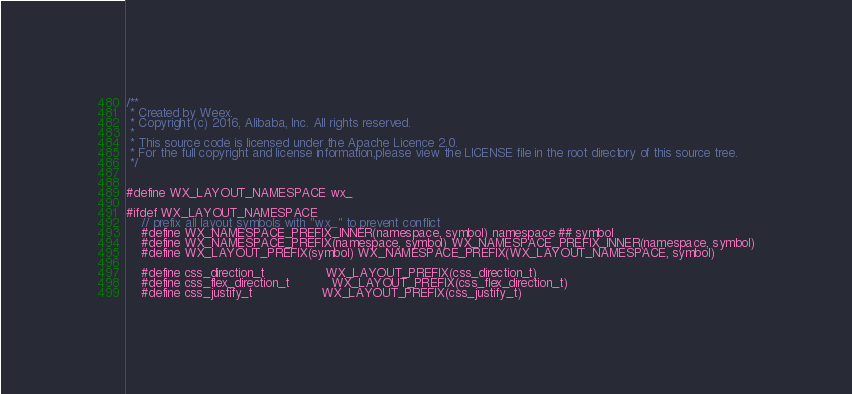<code> <loc_0><loc_0><loc_500><loc_500><_C_>/**
 * Created by Weex.
 * Copyright (c) 2016, Alibaba, Inc. All rights reserved.
 *
 * This source code is licensed under the Apache Licence 2.0.
 * For the full copyright and license information,please view the LICENSE file in the root directory of this source tree.
 */


#define WX_LAYOUT_NAMESPACE wx_

#ifdef WX_LAYOUT_NAMESPACE
    // prefix all layout symbols with "wx_" to prevent conflict
    #define WX_NAMESPACE_PREFIX_INNER(namespace, symbol) namespace ## symbol
    #define WX_NAMESPACE_PREFIX(namespace, symbol) WX_NAMESPACE_PREFIX_INNER(namespace, symbol)
    #define WX_LAYOUT_PREFIX(symbol) WX_NAMESPACE_PREFIX(WX_LAYOUT_NAMESPACE, symbol)

    #define css_direction_t                WX_LAYOUT_PREFIX(css_direction_t)
    #define css_flex_direction_t           WX_LAYOUT_PREFIX(css_flex_direction_t)
    #define css_justify_t                  WX_LAYOUT_PREFIX(css_justify_t)</code> 